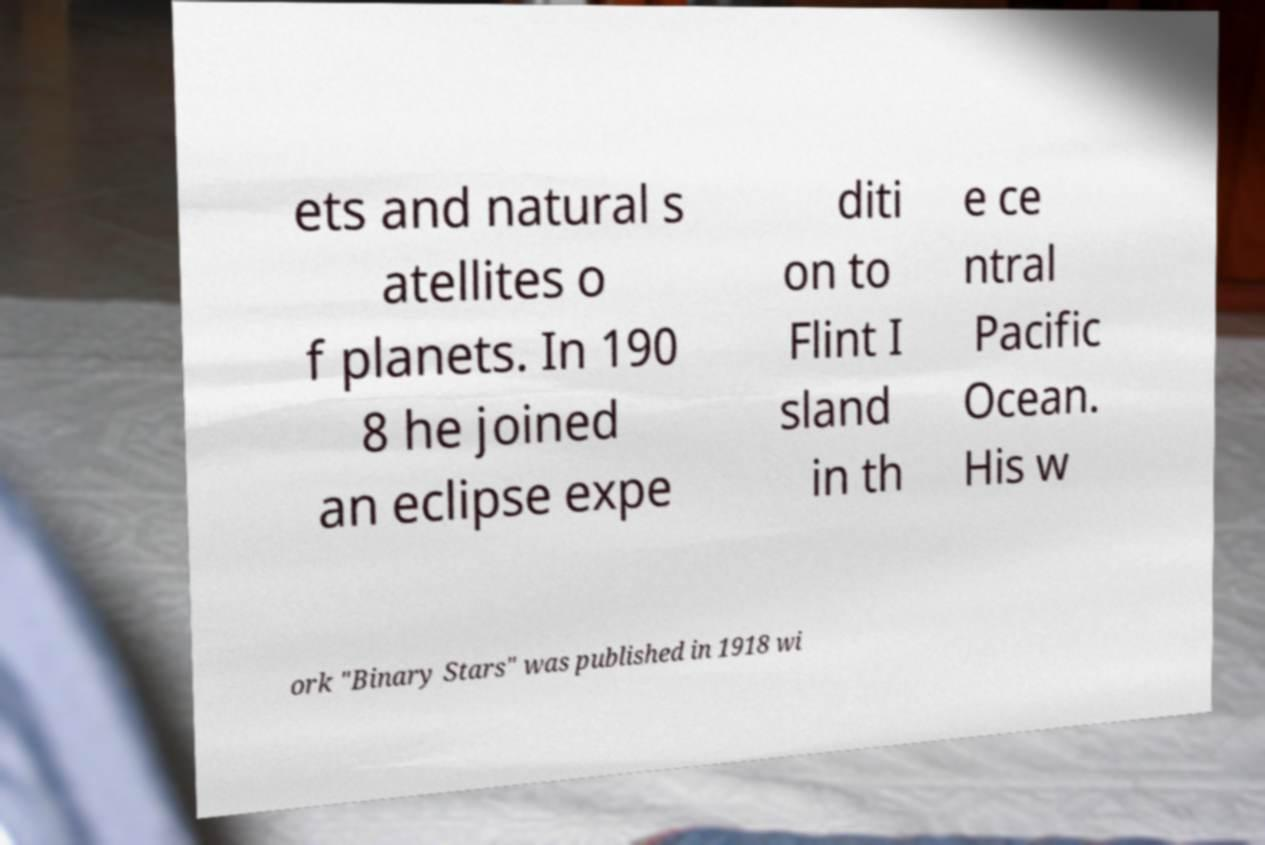Can you read and provide the text displayed in the image?This photo seems to have some interesting text. Can you extract and type it out for me? ets and natural s atellites o f planets. In 190 8 he joined an eclipse expe diti on to Flint I sland in th e ce ntral Pacific Ocean. His w ork "Binary Stars" was published in 1918 wi 